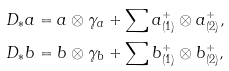<formula> <loc_0><loc_0><loc_500><loc_500>D _ { \ast } a & = a \otimes \gamma _ { a } + \sum a _ { ( 1 ) } ^ { + } \otimes a _ { ( 2 ) } ^ { + } , \\ D _ { \ast } b & = b \otimes \gamma _ { b } + \sum b _ { ( 1 ) } ^ { + } \otimes b _ { ( 2 ) } ^ { + } ,</formula> 